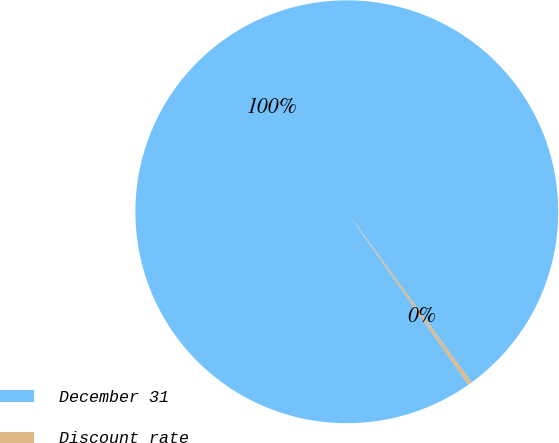Convert chart to OTSL. <chart><loc_0><loc_0><loc_500><loc_500><pie_chart><fcel>December 31<fcel>Discount rate<nl><fcel>99.7%<fcel>0.3%<nl></chart> 